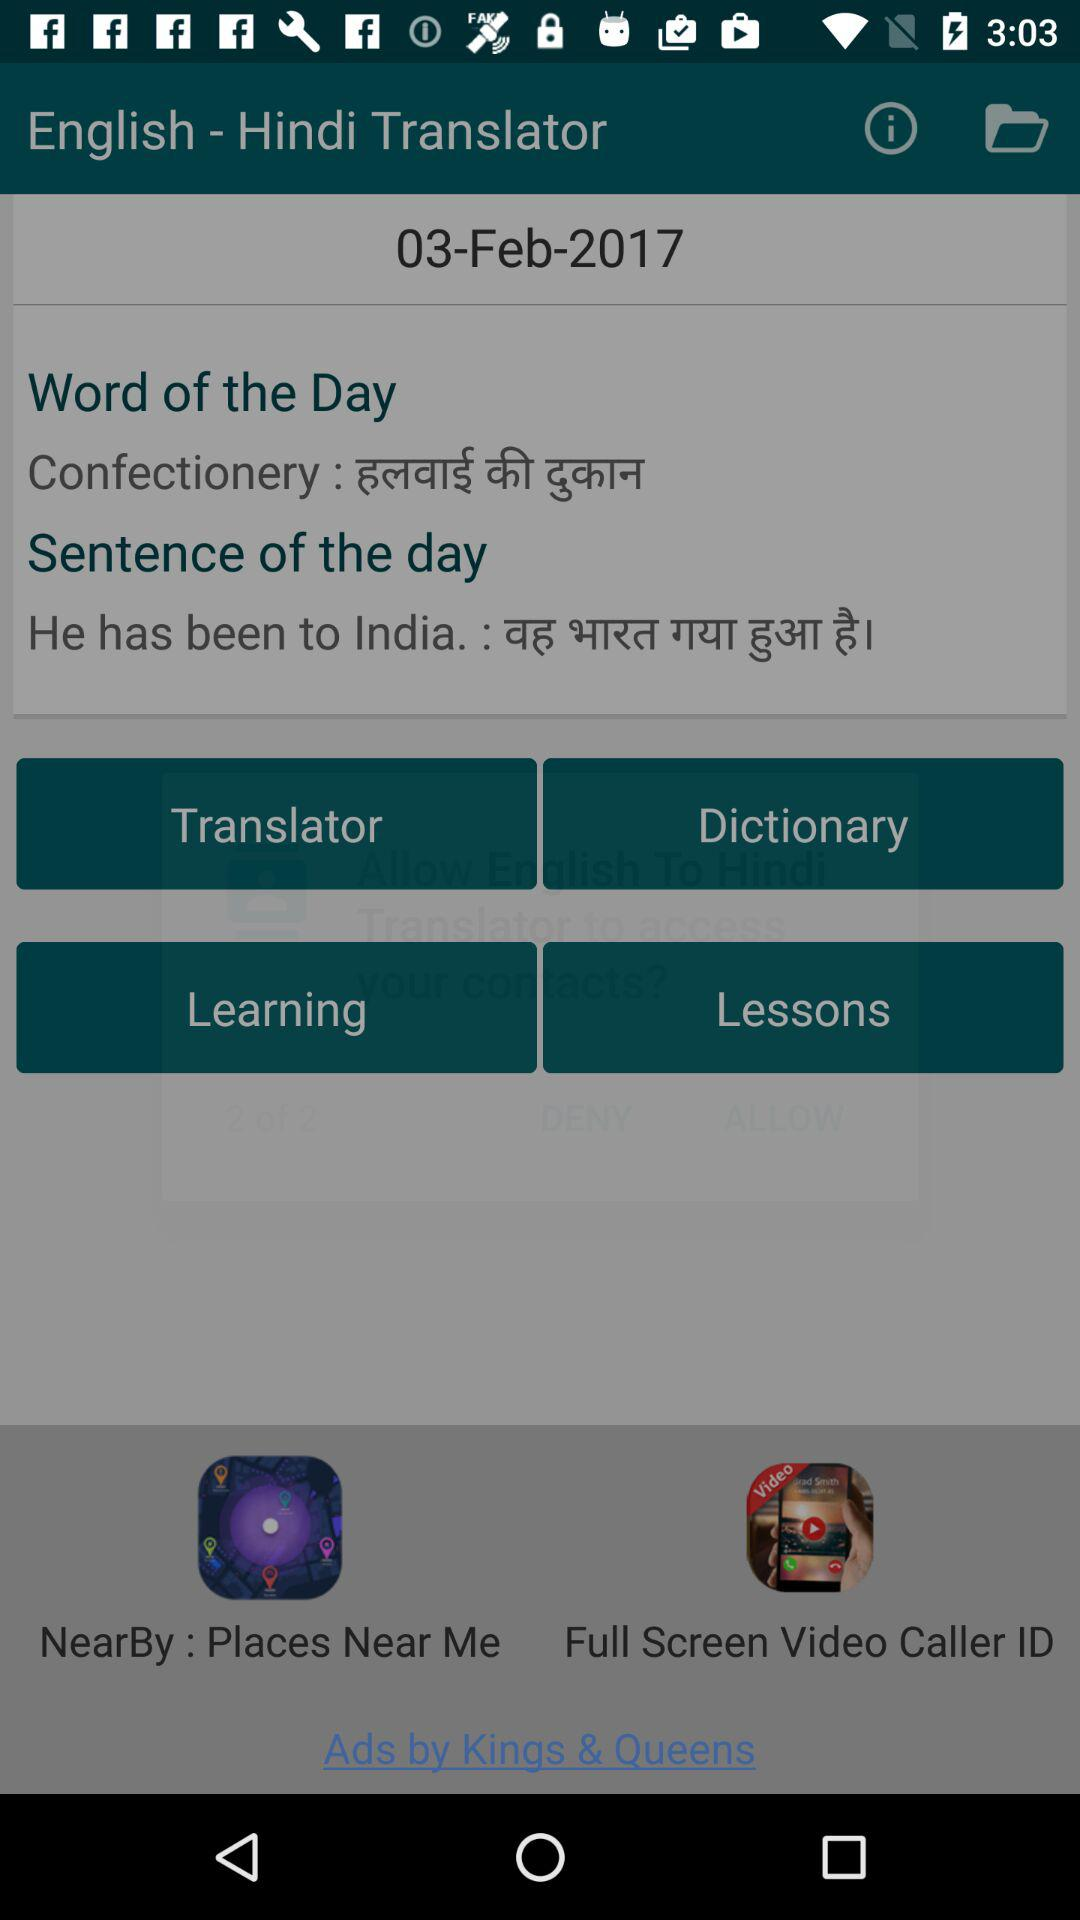What is the date? The date is February 3, 2017. 